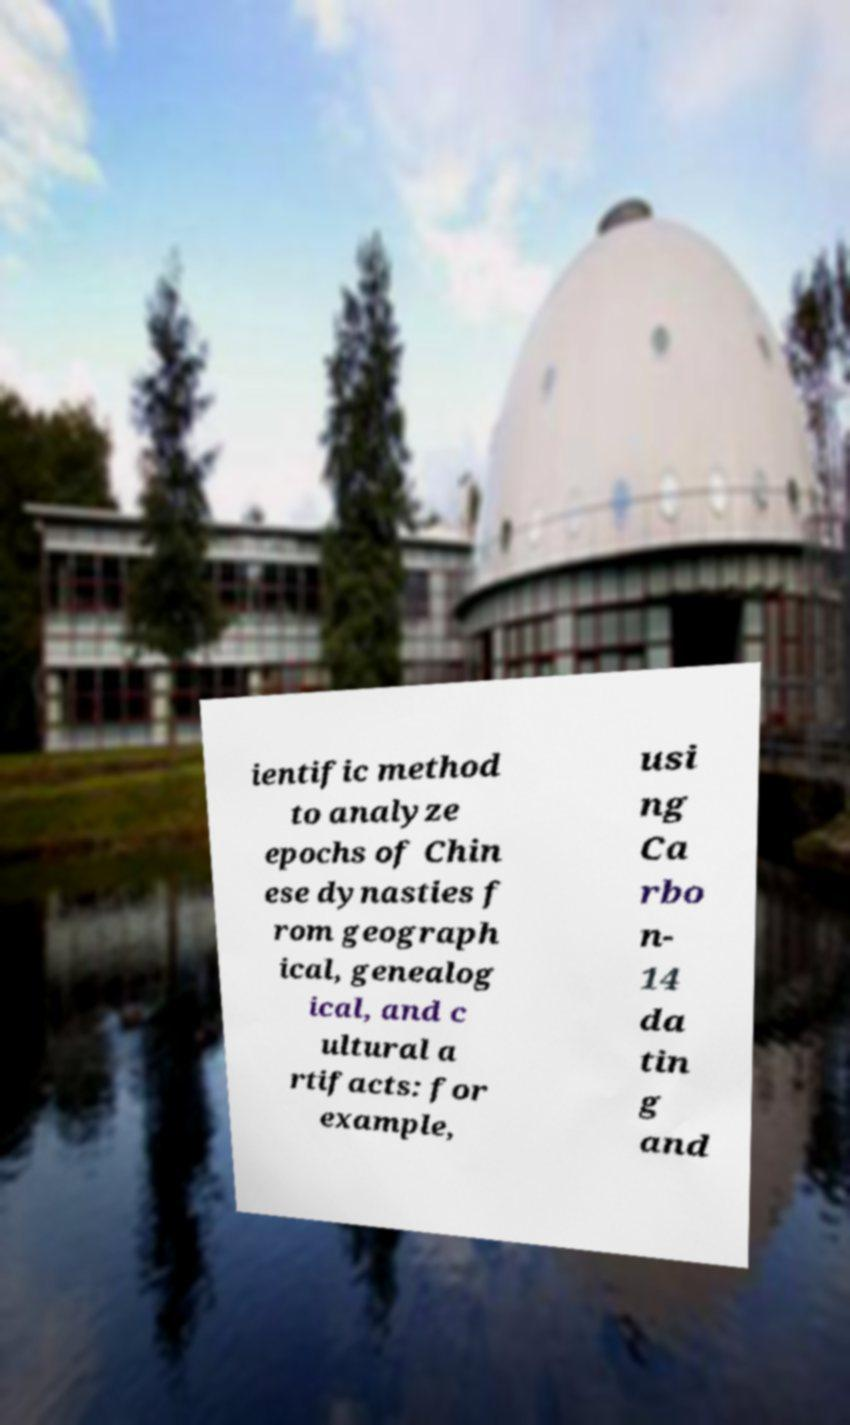Could you assist in decoding the text presented in this image and type it out clearly? ientific method to analyze epochs of Chin ese dynasties f rom geograph ical, genealog ical, and c ultural a rtifacts: for example, usi ng Ca rbo n- 14 da tin g and 